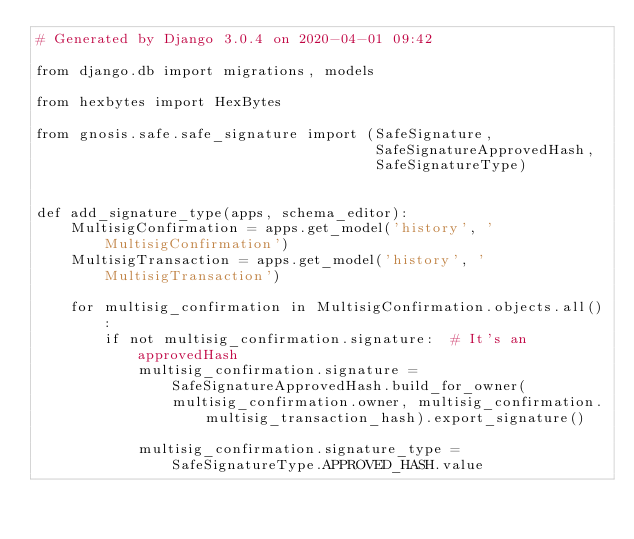Convert code to text. <code><loc_0><loc_0><loc_500><loc_500><_Python_># Generated by Django 3.0.4 on 2020-04-01 09:42

from django.db import migrations, models

from hexbytes import HexBytes

from gnosis.safe.safe_signature import (SafeSignature,
                                        SafeSignatureApprovedHash,
                                        SafeSignatureType)


def add_signature_type(apps, schema_editor):
    MultisigConfirmation = apps.get_model('history', 'MultisigConfirmation')
    MultisigTransaction = apps.get_model('history', 'MultisigTransaction')

    for multisig_confirmation in MultisigConfirmation.objects.all():
        if not multisig_confirmation.signature:  # It's an approvedHash
            multisig_confirmation.signature = SafeSignatureApprovedHash.build_for_owner(
                multisig_confirmation.owner, multisig_confirmation.multisig_transaction_hash).export_signature()

            multisig_confirmation.signature_type = SafeSignatureType.APPROVED_HASH.value</code> 